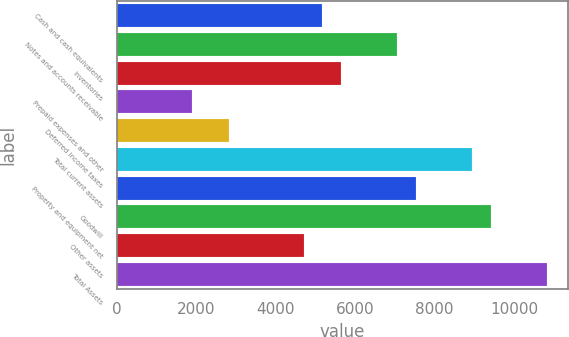Convert chart to OTSL. <chart><loc_0><loc_0><loc_500><loc_500><bar_chart><fcel>Cash and cash equivalents<fcel>Notes and accounts receivable<fcel>Inventories<fcel>Prepaid expenses and other<fcel>Deferred income taxes<fcel>Total current assets<fcel>Property and equipment net<fcel>Goodwill<fcel>Other assets<fcel>Total Assets<nl><fcel>5174.42<fcel>7055.7<fcel>5644.74<fcel>1882.18<fcel>2822.82<fcel>8936.98<fcel>7526.02<fcel>9407.3<fcel>4704.1<fcel>10818.3<nl></chart> 